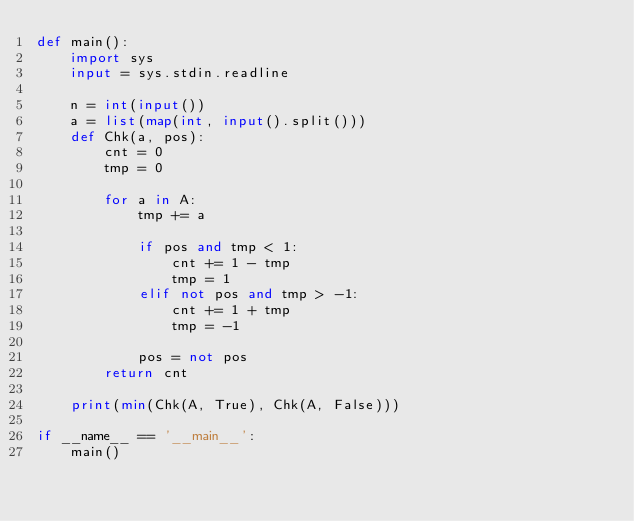Convert code to text. <code><loc_0><loc_0><loc_500><loc_500><_Python_>def main():
    import sys
    input = sys.stdin.readline

    n = int(input())
    a = list(map(int, input().split()))
    def Chk(a, pos):
        cnt = 0
        tmp = 0

        for a in A:
            tmp += a

            if pos and tmp < 1:
                cnt += 1 - tmp
                tmp = 1
            elif not pos and tmp > -1:
                cnt += 1 + tmp
                tmp = -1

            pos = not pos
        return cnt

    print(min(Chk(A, True), Chk(A, False)))
    
if __name__ == '__main__':
    main()</code> 